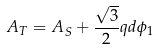<formula> <loc_0><loc_0><loc_500><loc_500>A _ { T } = A _ { S } + \frac { \sqrt { 3 } } { 2 } q d \phi _ { 1 }</formula> 